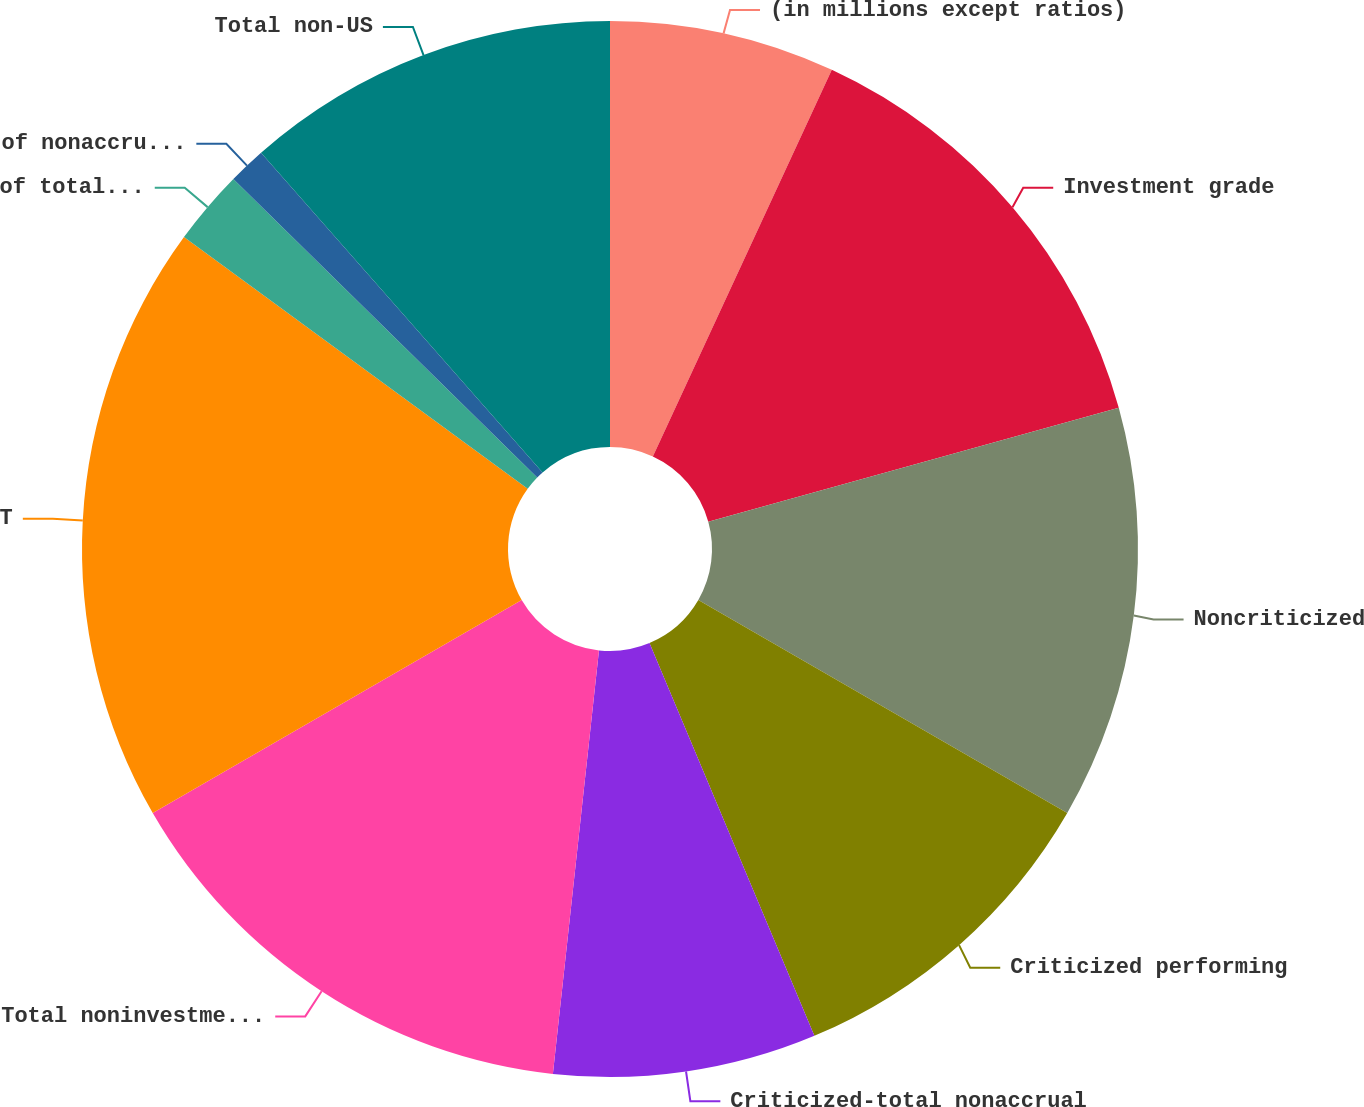Convert chart. <chart><loc_0><loc_0><loc_500><loc_500><pie_chart><fcel>(in millions except ratios)<fcel>Investment grade<fcel>Noncriticized<fcel>Criticized performing<fcel>Criticized-total nonaccrual<fcel>Total noninvestment grade<fcel>Total retained loans<fcel>of total criticized to total<fcel>of nonaccrual loans to total<fcel>Total non-US<nl><fcel>6.9%<fcel>13.79%<fcel>12.64%<fcel>10.34%<fcel>8.05%<fcel>14.94%<fcel>18.39%<fcel>2.3%<fcel>1.15%<fcel>11.49%<nl></chart> 